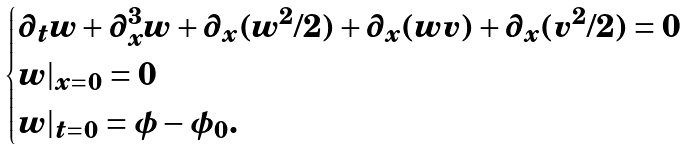<formula> <loc_0><loc_0><loc_500><loc_500>\begin{cases} \partial _ { t } w + \partial _ { x } ^ { 3 } w + \partial _ { x } ( w ^ { 2 } / 2 ) + \partial _ { x } ( w v ) + \partial _ { x } ( v ^ { 2 } / 2 ) = 0 \\ w | _ { x = 0 } = 0 \\ w | _ { t = 0 } = \phi - \phi _ { 0 } . \end{cases}</formula> 